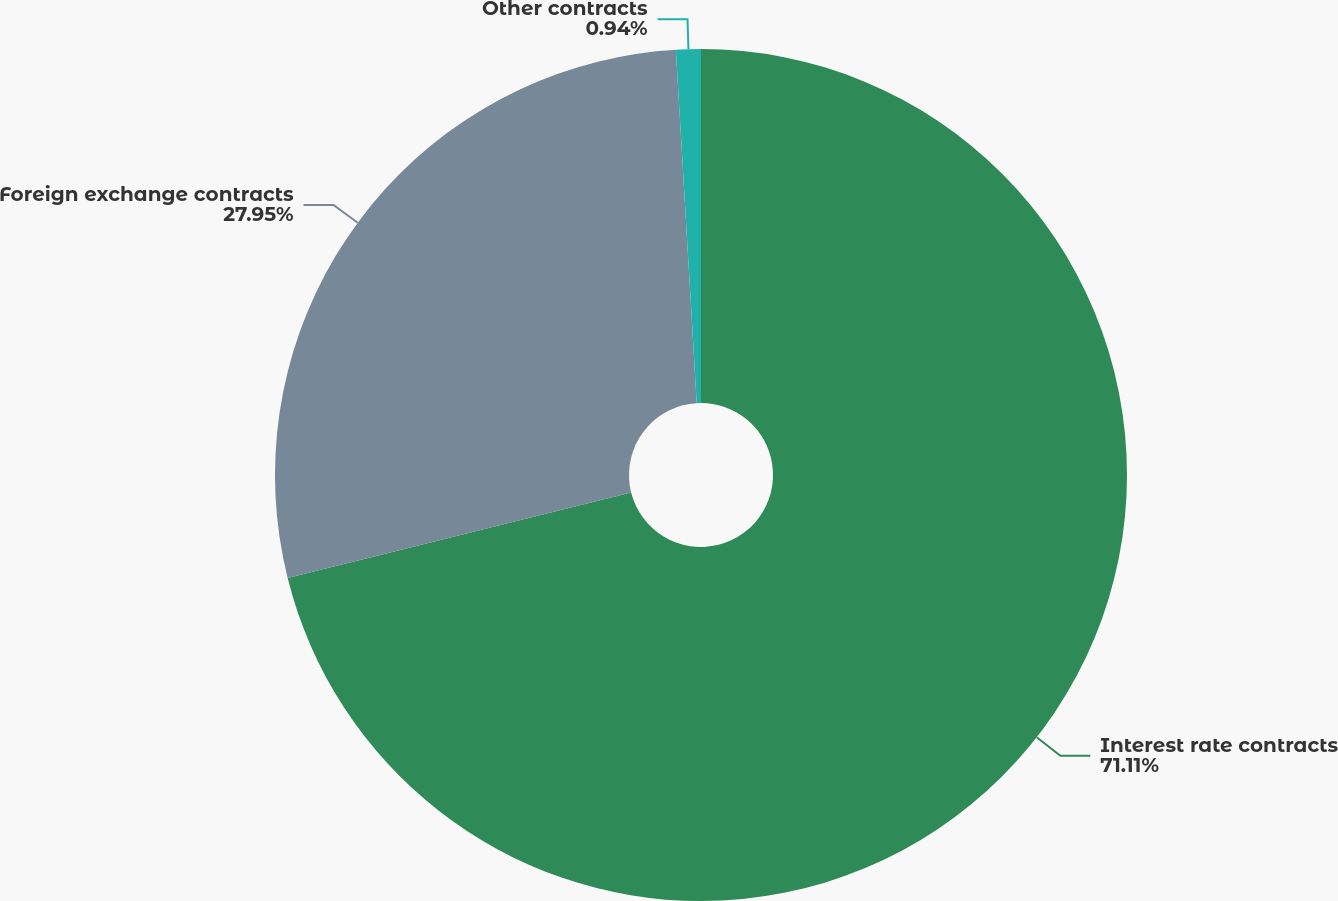Convert chart to OTSL. <chart><loc_0><loc_0><loc_500><loc_500><pie_chart><fcel>Interest rate contracts<fcel>Foreign exchange contracts<fcel>Other contracts<nl><fcel>71.11%<fcel>27.95%<fcel>0.94%<nl></chart> 